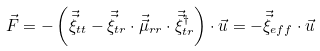<formula> <loc_0><loc_0><loc_500><loc_500>\vec { F } = - \left ( \vec { \vec { \xi } } _ { t t } - \vec { \vec { \xi } } _ { t r } \cdot \vec { \vec { \mu } } _ { r r } \cdot \vec { \vec { \xi } } _ { t r } ^ { \dag } \right ) \cdot \vec { u } = - \vec { \vec { \xi } } _ { e f f } \cdot \vec { u }</formula> 